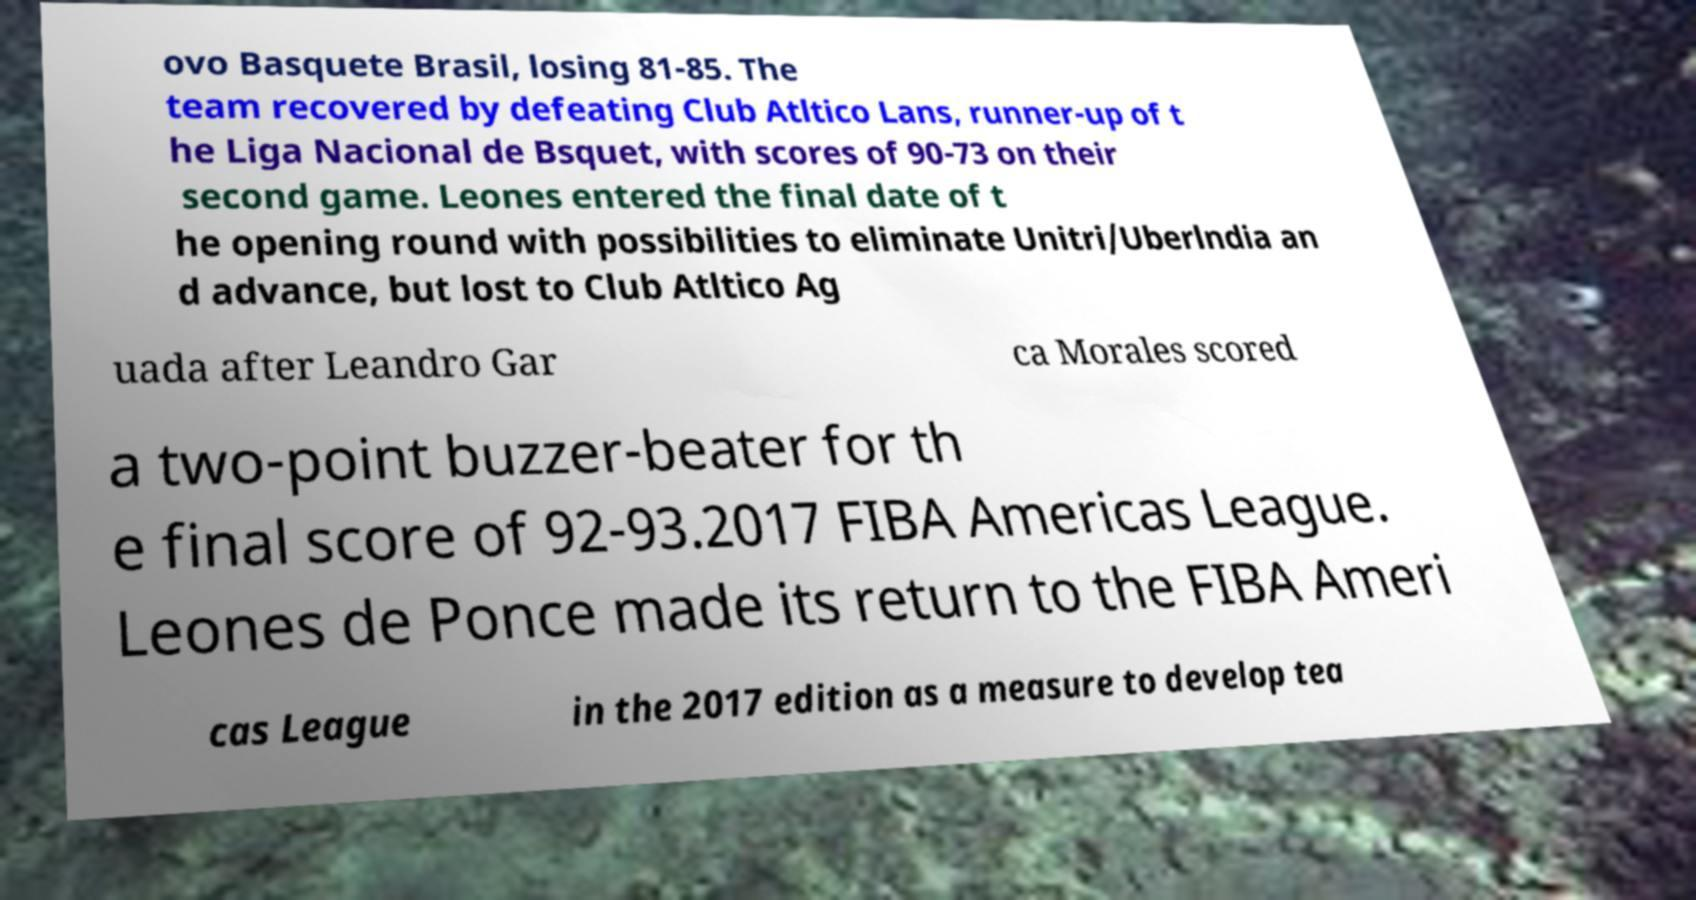Could you extract and type out the text from this image? ovo Basquete Brasil, losing 81-85. The team recovered by defeating Club Atltico Lans, runner-up of t he Liga Nacional de Bsquet, with scores of 90-73 on their second game. Leones entered the final date of t he opening round with possibilities to eliminate Unitri/Uberlndia an d advance, but lost to Club Atltico Ag uada after Leandro Gar ca Morales scored a two-point buzzer-beater for th e final score of 92-93.2017 FIBA Americas League. Leones de Ponce made its return to the FIBA Ameri cas League in the 2017 edition as a measure to develop tea 